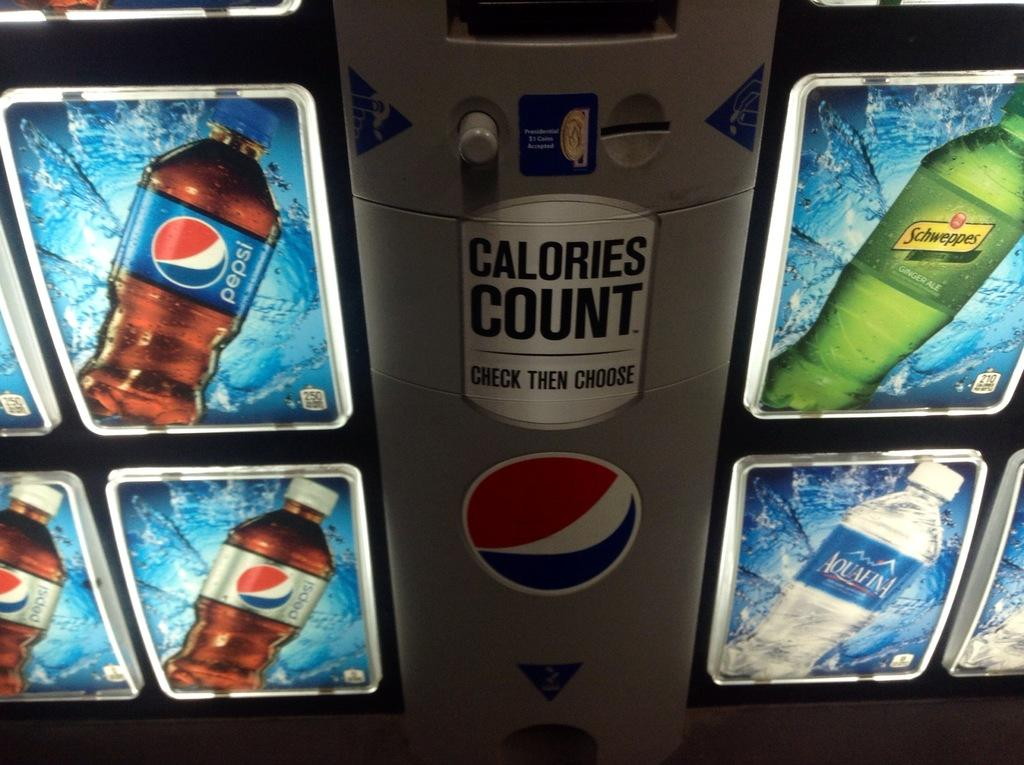<image>
Create a compact narrative representing the image presented. A pop machine that has says Calories Count Check Then Choose in the middle of the machine. 